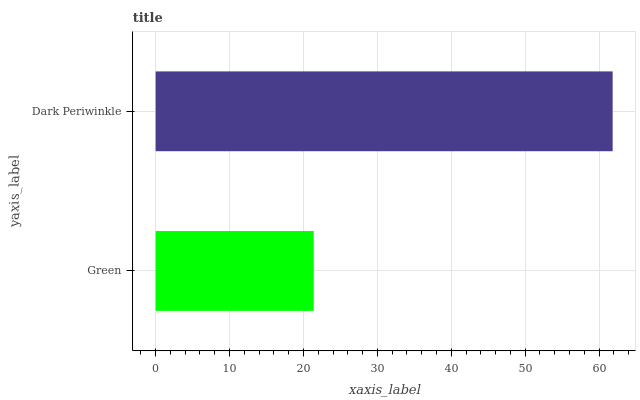Is Green the minimum?
Answer yes or no. Yes. Is Dark Periwinkle the maximum?
Answer yes or no. Yes. Is Dark Periwinkle the minimum?
Answer yes or no. No. Is Dark Periwinkle greater than Green?
Answer yes or no. Yes. Is Green less than Dark Periwinkle?
Answer yes or no. Yes. Is Green greater than Dark Periwinkle?
Answer yes or no. No. Is Dark Periwinkle less than Green?
Answer yes or no. No. Is Dark Periwinkle the high median?
Answer yes or no. Yes. Is Green the low median?
Answer yes or no. Yes. Is Green the high median?
Answer yes or no. No. Is Dark Periwinkle the low median?
Answer yes or no. No. 